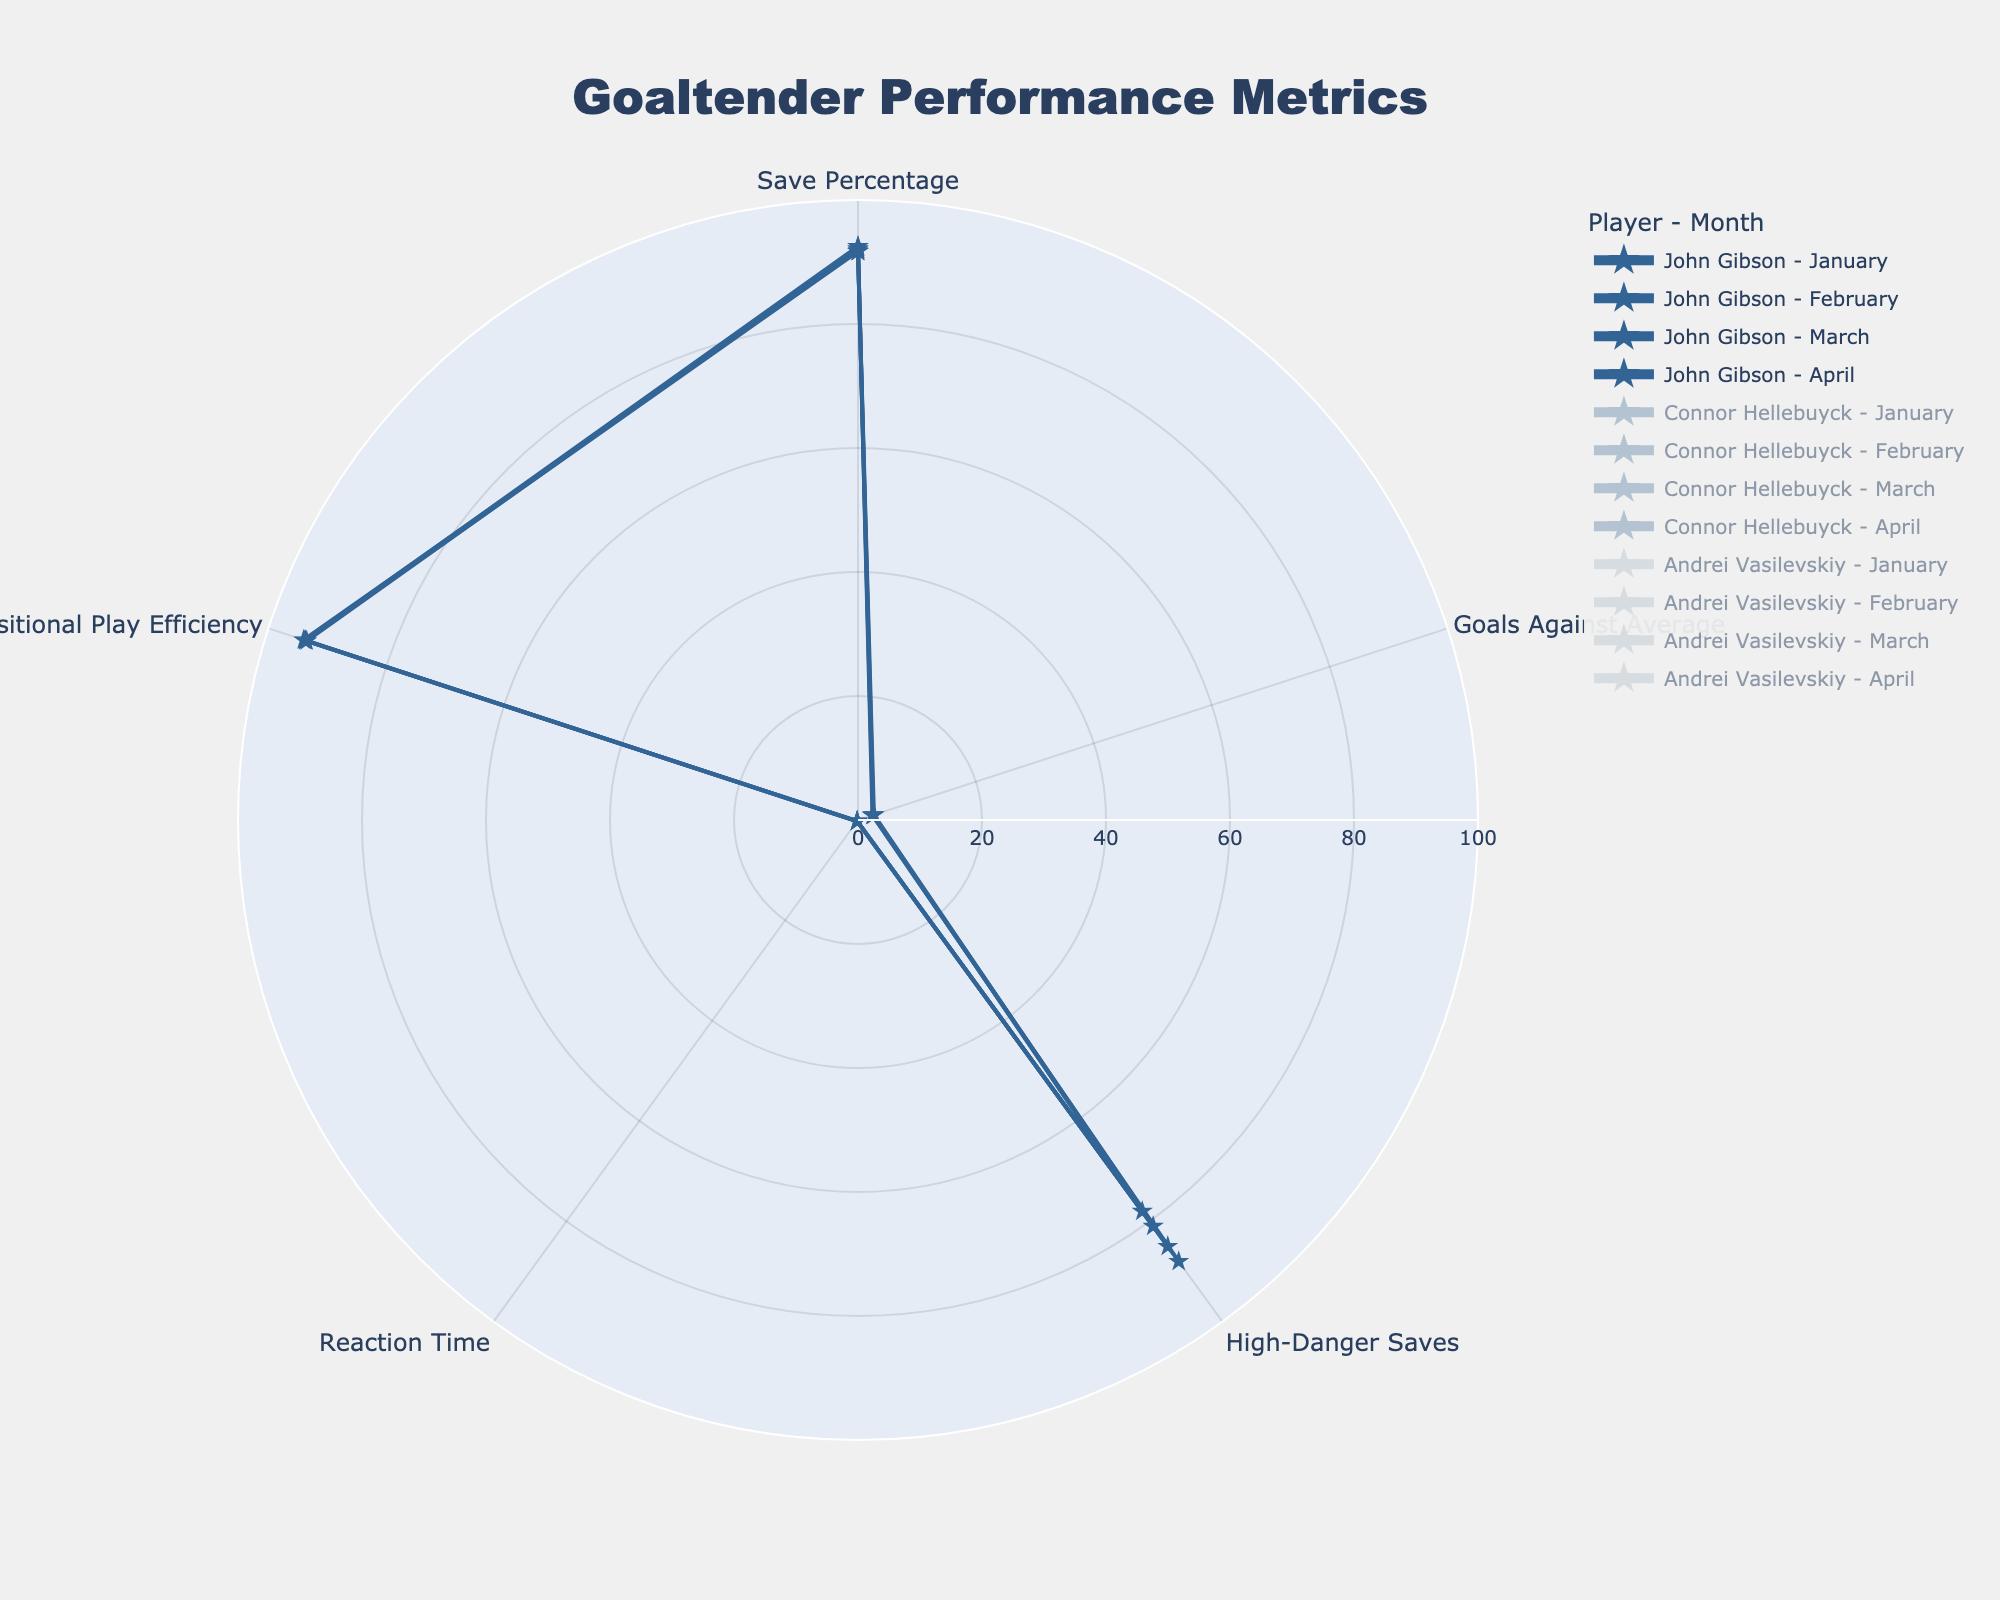How many goaltenders' performance metrics are visualized in the radar charts? There are three goaltenders: John Gibson, Connor Hellebuyck, and Andrei Vasilevskiy.
Answer: 3 Which month shows the highest save percentage for Connor Hellebuyck? By comparing the radar charts for Connor Hellebuyck across all months, we see that January shows the highest save percentage.
Answer: January Which goaltender had the lowest goals against average in April? By examining the radar charts for April, Connor Hellebuyck has the lowest goals against average compared to John Gibson and Andrei Vasilevskiy.
Answer: Connor Hellebuyck What is the average positional play efficiency for John Gibson across all months? Calculate the average of John Gibson's positional play efficiency for January (93.5), February (94.0), March (93.8), and April (93.7). The sum is 93.5 + 94.0 + 93.8 + 93.7 = 375, and the average is 375 / 4.
Answer: 93.75 Which player and month has the fastest reaction time? By comparing the radar charts, Connor Hellebuyck in January and John Gibson in March both have the fastest reaction time of 0.21 seconds.
Answer: Connor Hellebuyck (January), John Gibson (March) How does Andrei Vasilevskiy's save percentage in March compare to his save percentage in February? Andrei Vasilevskiy's save percentage in March (92.0) is lower than in February (92.2).
Answer: Lower in March Which metric shows the most significant variation for John Gibson across the months? By observing the radar charts, Goals Against Average shows the highest variation for John Gibson, ranging from 2.45 in March to 2.70 in April.
Answer: Goals Against Average Is there a consistent trend in high-danger saves for Andrei Vasilevskiy over the months? By examining the radar charts, Andrei Vasilevskiy's high-danger saves decrease from January (82) and February (86) to March (84) and April (80), indicating a decreasing trend.
Answer: Decreasing trend If you were to rank the players' positional play efficiency in March, what would the order be? For March, compare positional play efficiency: Connor Hellebuyck (94.6), John Gibson (93.8), Andrei Vasilevskiy (93.9). The ranking is: Connor Hellebuyck > Andrei Vasilevskiy > John Gibson.
Answer: Connor Hellebuyck, Andrei Vasilevskiy, John Gibson 